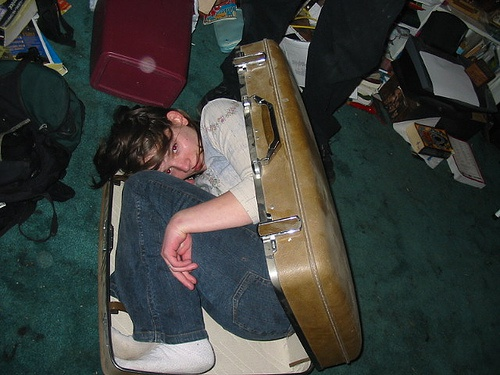Describe the objects in this image and their specific colors. I can see people in gray, black, darkblue, blue, and darkgray tones, suitcase in gray, black, olive, and darkgray tones, people in gray, black, darkgray, and darkgreen tones, backpack in gray, black, teal, and navy tones, and suitcase in gray, maroon, black, and brown tones in this image. 